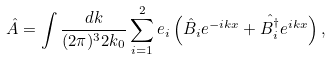<formula> <loc_0><loc_0><loc_500><loc_500>\hat { A } = \int \frac { d { k } } { ( 2 \pi ) ^ { 3 } 2 k _ { 0 } } \sum _ { i = 1 } ^ { 2 } { e } _ { i } \left ( \hat { B } _ { i } e ^ { - i { k x } } + \hat { B _ { i } ^ { \dagger } } e ^ { i { k x } } \right ) ,</formula> 